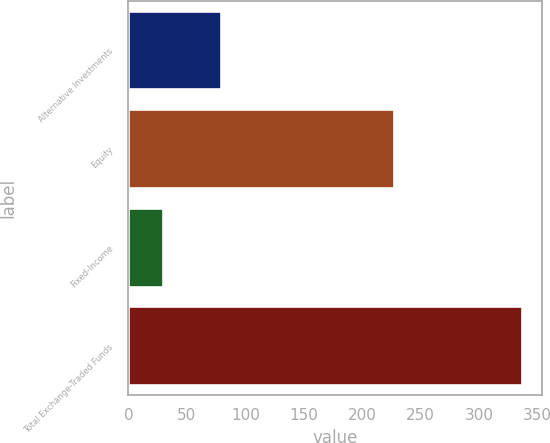Convert chart. <chart><loc_0><loc_0><loc_500><loc_500><bar_chart><fcel>Alternative Investments<fcel>Equity<fcel>Fixed-Income<fcel>Total Exchange-Traded Funds<nl><fcel>79<fcel>227<fcel>30<fcel>337<nl></chart> 